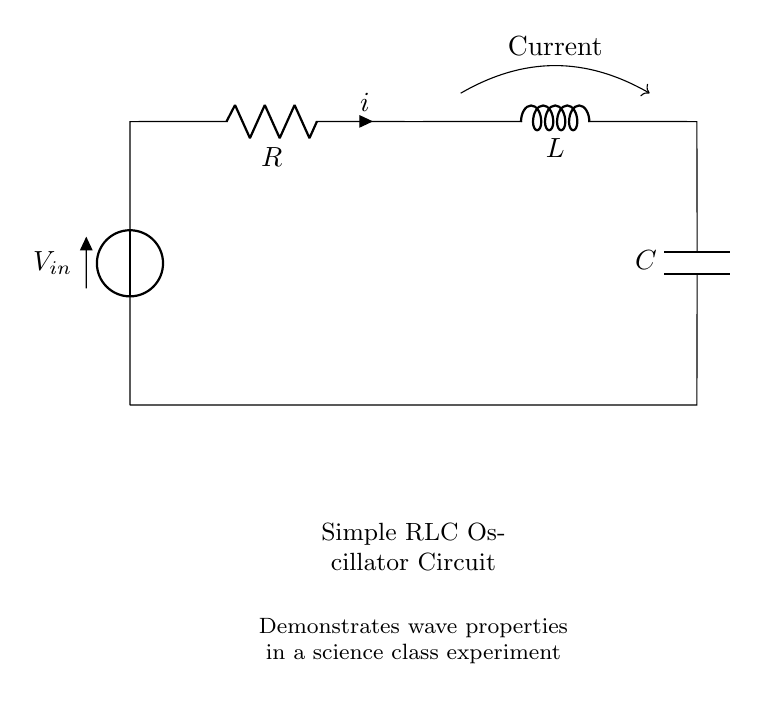What components are in this circuit? The circuit contains a resistor, inductor, and capacitor, which are the essential components of an RLC oscillator.
Answer: Resistor, Inductor, Capacitor What is the input voltage of the circuit? The voltage is indicated as V in the diagram, serving as the input for the circuit.
Answer: V What direction does the current flow in this circuit? The current flows from the positive terminal of the voltage source through the resistor, inductor, and capacitor, completing the loop back to the voltage source.
Answer: Clockwise How is the capacitor connected in the circuit? The capacitor is connected in parallel with the resistor and inductor, completing a closed loop with the voltage source.
Answer: In parallel What is the purpose of the inductor in this circuit? The inductor stores energy in a magnetic field when current passes through it, affecting the oscillation behavior in the circuit.
Answer: Energy storage Explain how the components interact to produce oscillations. The circuit operates as an oscillator due to the combination of the capacitance and inductance, which creates a natural resonant frequency. When the circuit is energized, the capacitor charges and discharges through the inductor, creating a periodic current and voltage oscillation. The resistor provides damping, which affects the amplitude of oscillations.
Answer: Resonance and energy transfer 